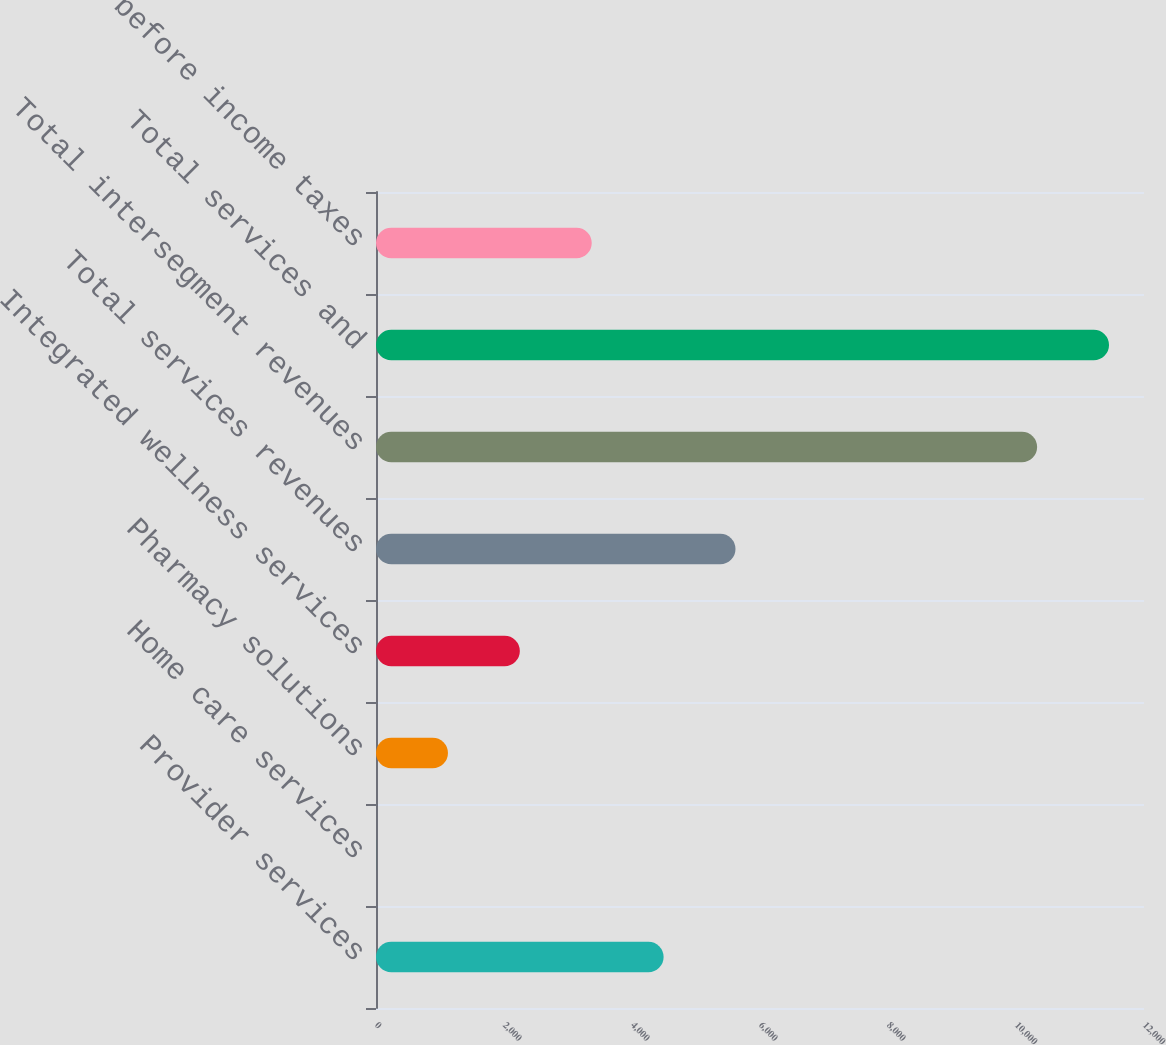Convert chart to OTSL. <chart><loc_0><loc_0><loc_500><loc_500><bar_chart><fcel>Provider services<fcel>Home care services<fcel>Pharmacy solutions<fcel>Integrated wellness services<fcel>Total services revenues<fcel>Total intersegment revenues<fcel>Total services and<fcel>Income before income taxes<nl><fcel>4493.84<fcel>1.04<fcel>1124.24<fcel>2247.44<fcel>5617.04<fcel>10330<fcel>11453.2<fcel>3370.64<nl></chart> 